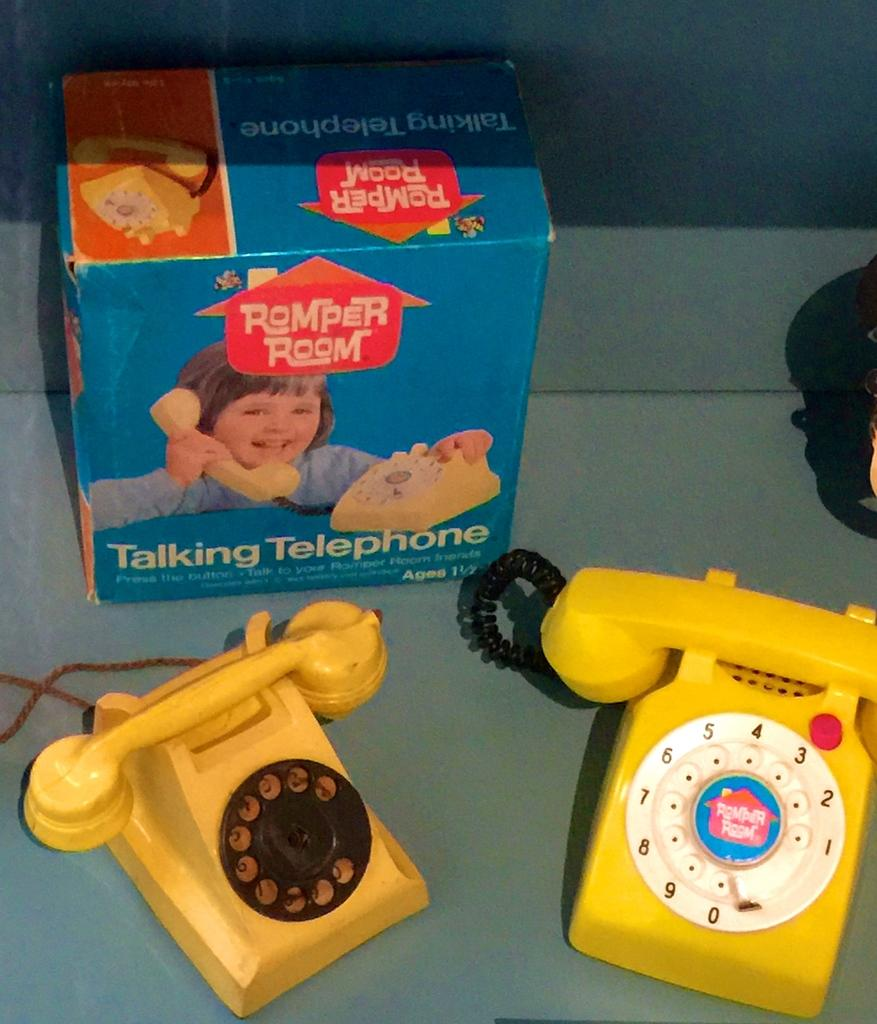Provide a one-sentence caption for the provided image. a couple toy phones with a box that says talking telephone. 